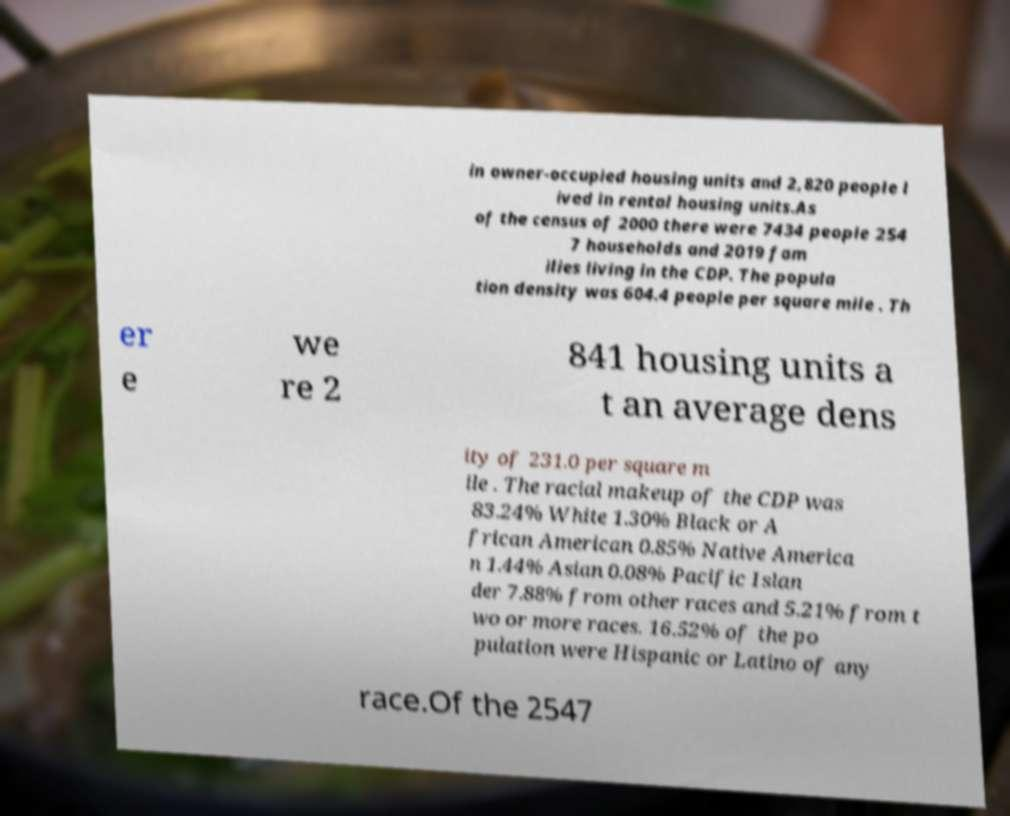For documentation purposes, I need the text within this image transcribed. Could you provide that? in owner-occupied housing units and 2,820 people l ived in rental housing units.As of the census of 2000 there were 7434 people 254 7 households and 2019 fam ilies living in the CDP. The popula tion density was 604.4 people per square mile . Th er e we re 2 841 housing units a t an average dens ity of 231.0 per square m ile . The racial makeup of the CDP was 83.24% White 1.30% Black or A frican American 0.85% Native America n 1.44% Asian 0.08% Pacific Islan der 7.88% from other races and 5.21% from t wo or more races. 16.52% of the po pulation were Hispanic or Latino of any race.Of the 2547 